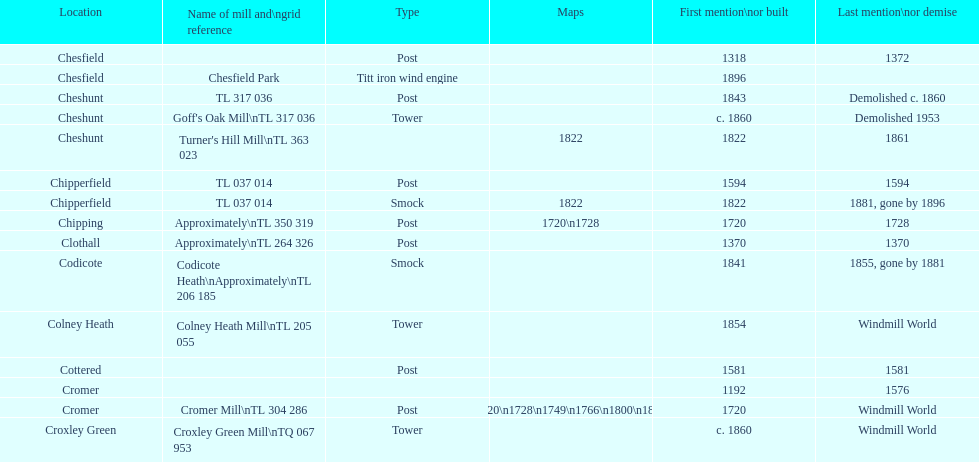How many locations have no photograph? 14. 